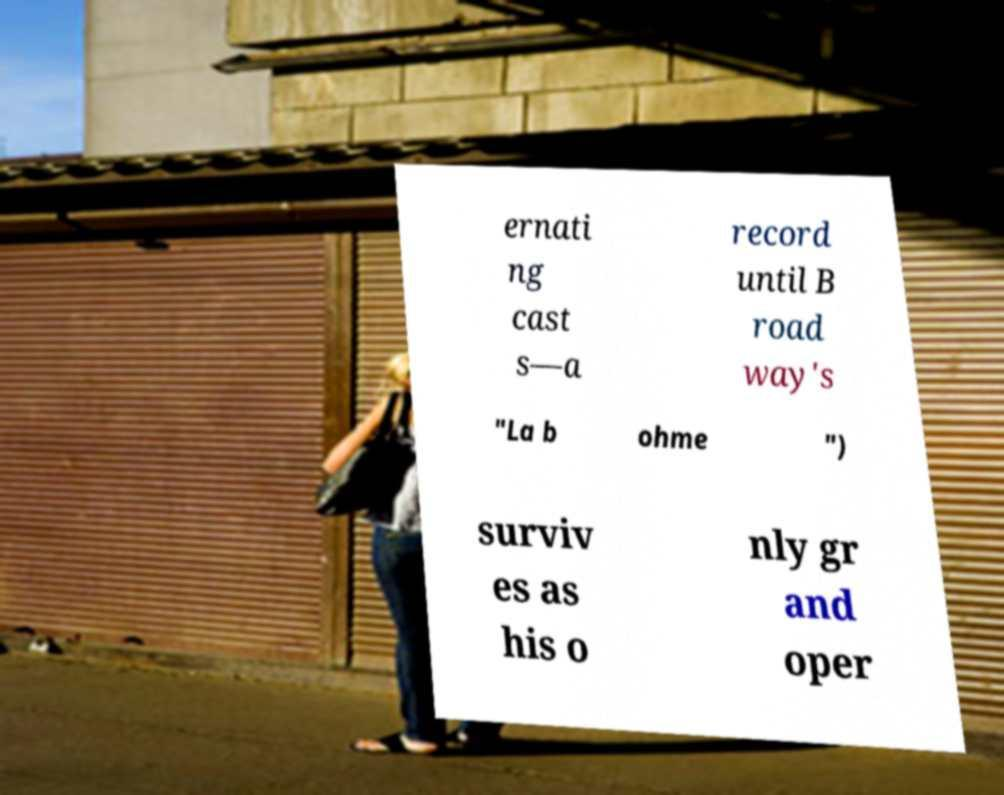Can you read and provide the text displayed in the image?This photo seems to have some interesting text. Can you extract and type it out for me? ernati ng cast s—a record until B road way's "La b ohme ") surviv es as his o nly gr and oper 